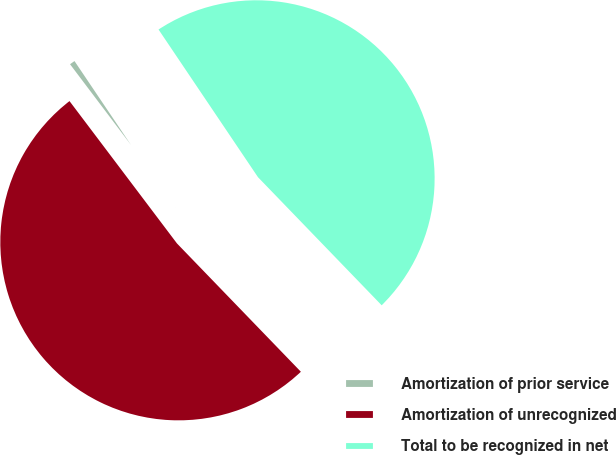Convert chart. <chart><loc_0><loc_0><loc_500><loc_500><pie_chart><fcel>Amortization of prior service<fcel>Amortization of unrecognized<fcel>Total to be recognized in net<nl><fcel>0.86%<fcel>51.93%<fcel>47.21%<nl></chart> 